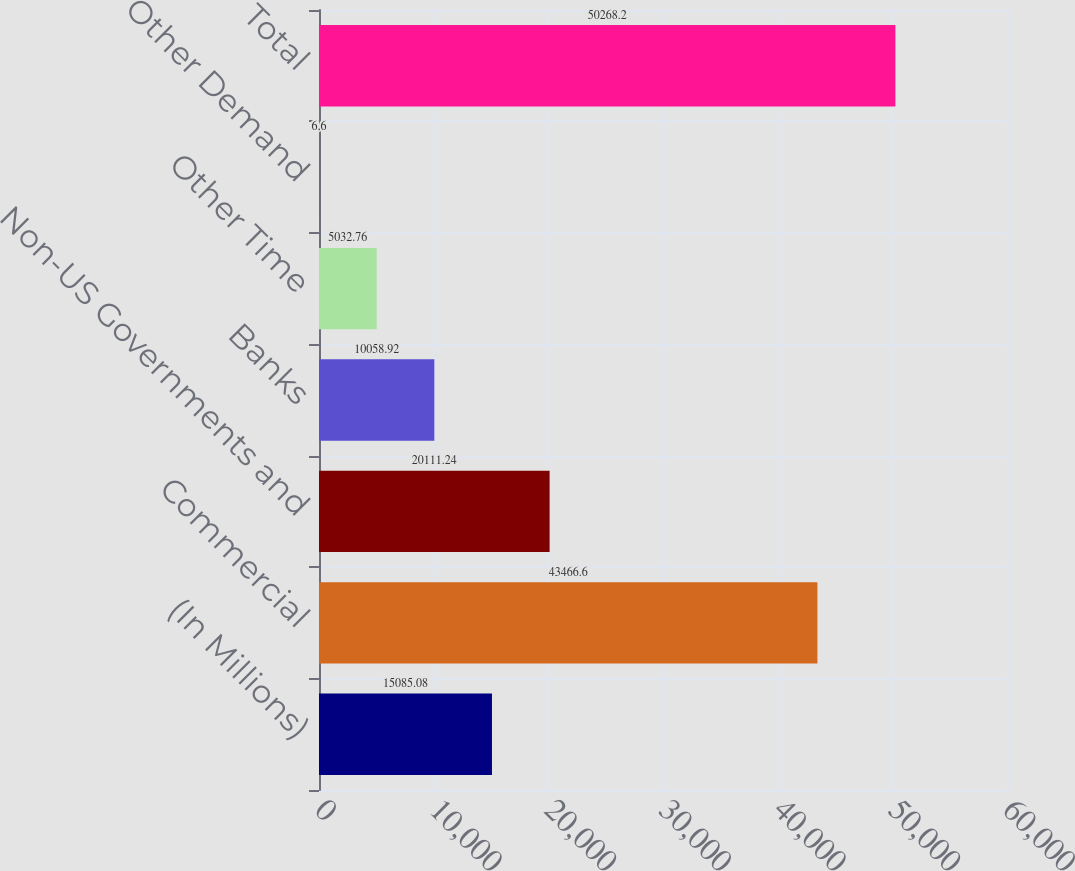Convert chart to OTSL. <chart><loc_0><loc_0><loc_500><loc_500><bar_chart><fcel>(In Millions)<fcel>Commercial<fcel>Non-US Governments and<fcel>Banks<fcel>Other Time<fcel>Other Demand<fcel>Total<nl><fcel>15085.1<fcel>43466.6<fcel>20111.2<fcel>10058.9<fcel>5032.76<fcel>6.6<fcel>50268.2<nl></chart> 